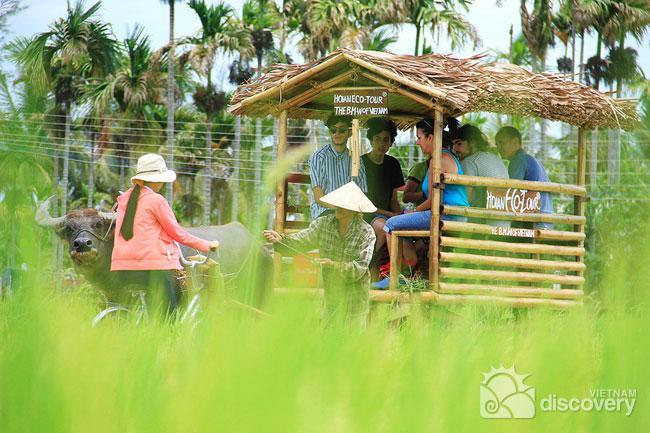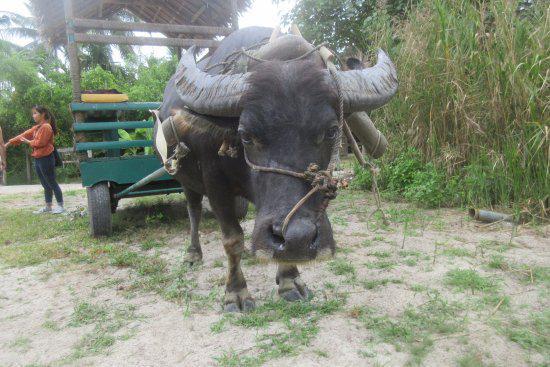The first image is the image on the left, the second image is the image on the right. For the images shown, is this caption "In the left image, two oxen are yolked to the cart." true? Answer yes or no. No. 